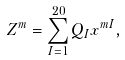<formula> <loc_0><loc_0><loc_500><loc_500>Z ^ { m } = \sum _ { I = 1 } ^ { 2 0 } Q _ { I } x ^ { m I } ,</formula> 